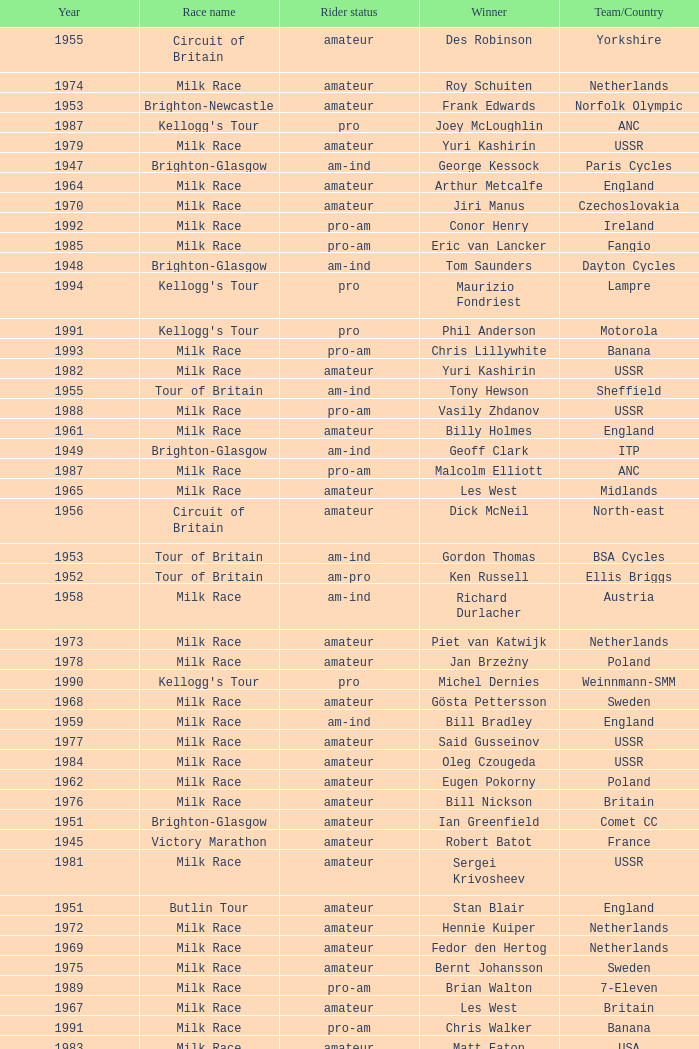Who was the winner in 1973 with an amateur rider status? Piet van Katwijk. 